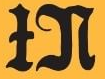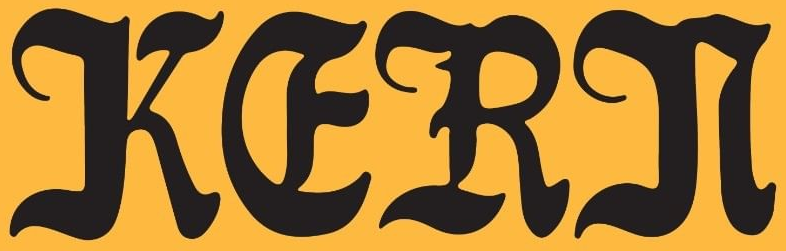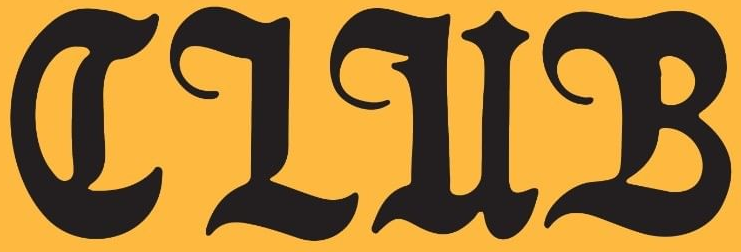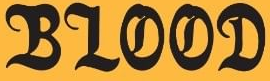Transcribe the words shown in these images in order, separated by a semicolon. IN; KERN; CLUB; BLOOD 